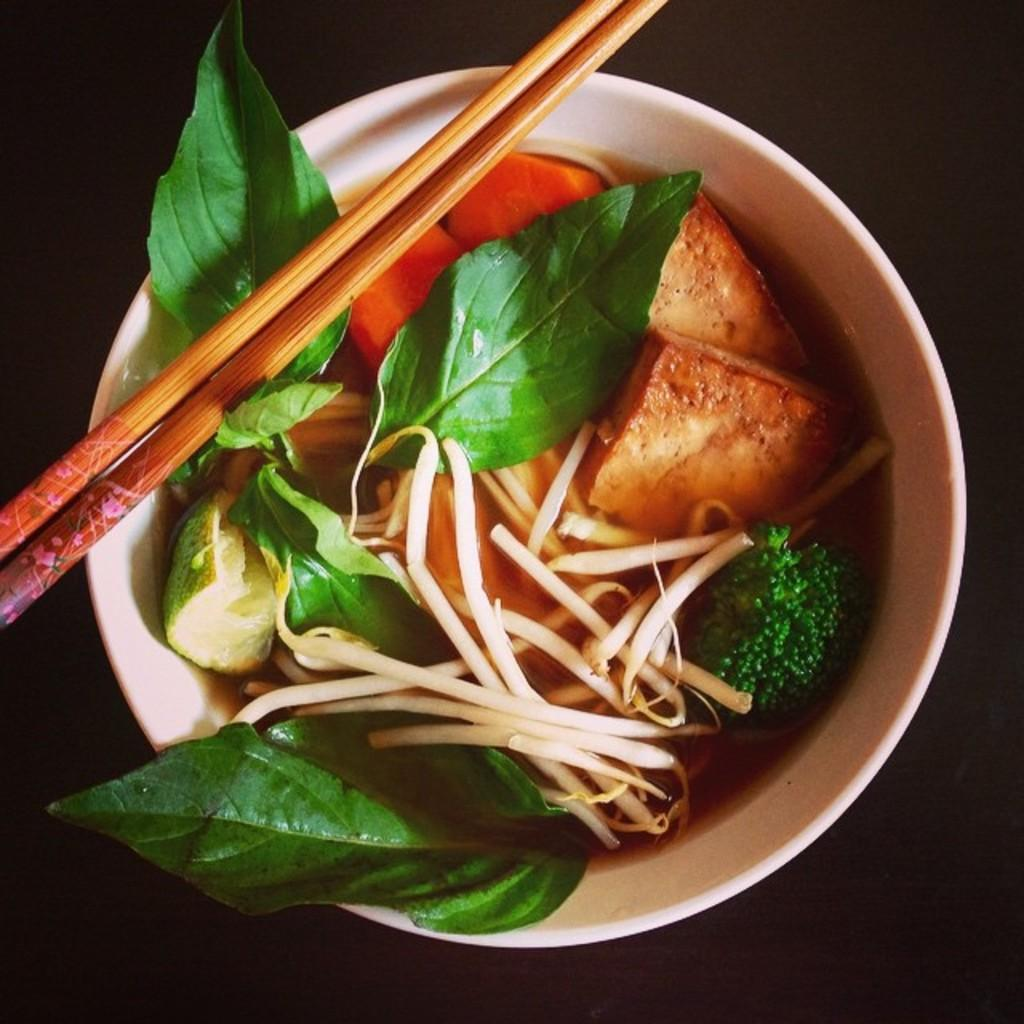What is in the bowl that is visible in the image? The bowl is filled with leaves, bread, carrots, and soup. What utensil is placed on top of the bowl? Chopsticks are present on top of the bowl. What type of nut can be seen in the image? There is no nut present in the image. What does the image smell like? The image does not have a smell, as it is a visual representation. 